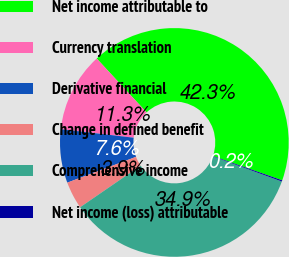Convert chart to OTSL. <chart><loc_0><loc_0><loc_500><loc_500><pie_chart><fcel>Net income attributable to<fcel>Currency translation<fcel>Derivative financial<fcel>Change in defined benefit<fcel>Comprehensive income<fcel>Net income (loss) attributable<nl><fcel>42.27%<fcel>11.27%<fcel>7.57%<fcel>3.87%<fcel>34.87%<fcel>0.17%<nl></chart> 